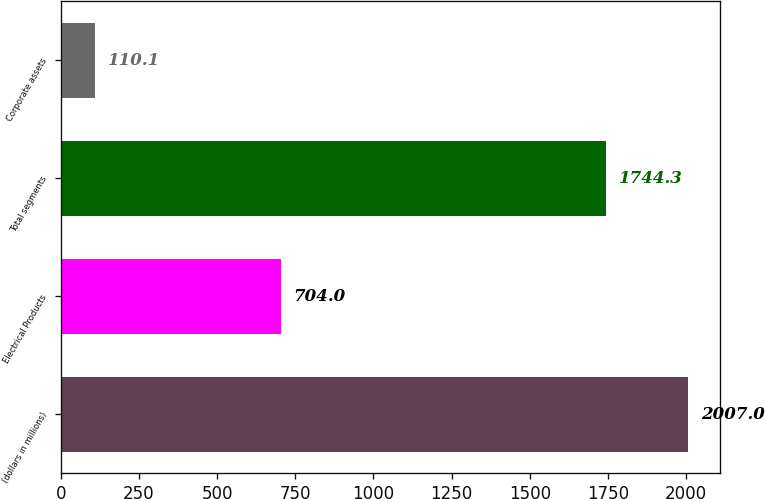Convert chart to OTSL. <chart><loc_0><loc_0><loc_500><loc_500><bar_chart><fcel>(dollars in millions)<fcel>Electrical Products<fcel>Total segments<fcel>Corporate assets<nl><fcel>2007<fcel>704<fcel>1744.3<fcel>110.1<nl></chart> 